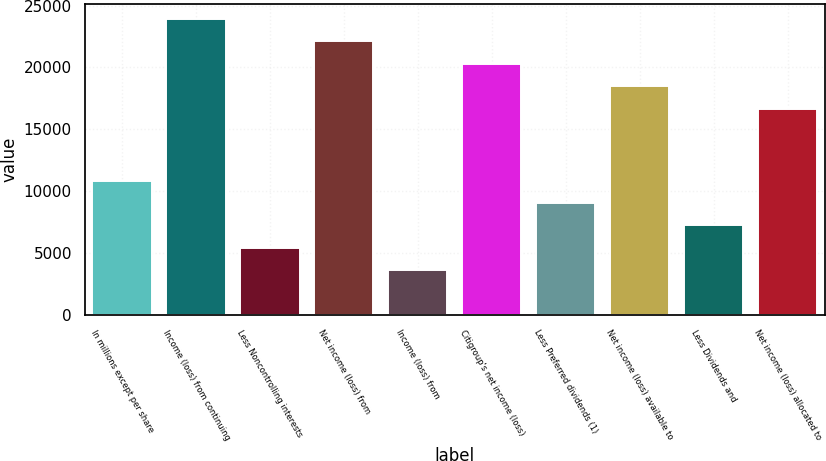Convert chart. <chart><loc_0><loc_0><loc_500><loc_500><bar_chart><fcel>In millions except per share<fcel>Income (loss) from continuing<fcel>Less Noncontrolling interests<fcel>Net income (loss) from<fcel>Income (loss) from<fcel>Citigroup's net income (loss)<fcel>Less Preferred dividends (1)<fcel>Net income (loss) available to<fcel>Less Dividends and<fcel>Net income (loss) allocated to<nl><fcel>10855.5<fcel>23904.5<fcel>5431.08<fcel>22096.4<fcel>3622.95<fcel>20288.3<fcel>9047.34<fcel>18480.1<fcel>7239.21<fcel>16672<nl></chart> 